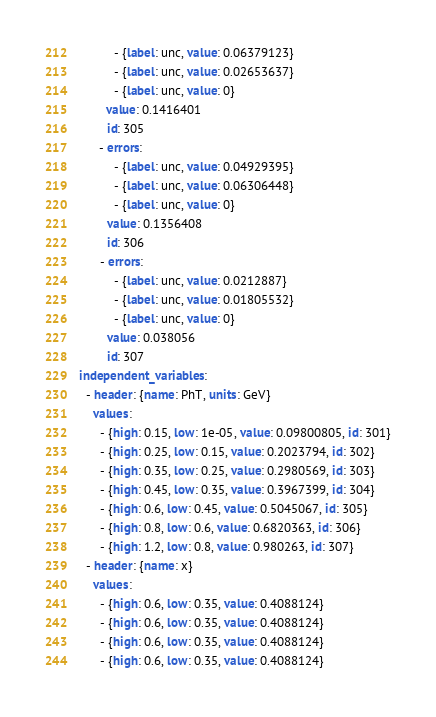Convert code to text. <code><loc_0><loc_0><loc_500><loc_500><_YAML_>          - {label: unc, value: 0.06379123}
          - {label: unc, value: 0.02653637}
          - {label: unc, value: 0}
        value: 0.1416401
        id: 305
      - errors:
          - {label: unc, value: 0.04929395}
          - {label: unc, value: 0.06306448}
          - {label: unc, value: 0}
        value: 0.1356408
        id: 306
      - errors:
          - {label: unc, value: 0.0212887}
          - {label: unc, value: 0.01805532}
          - {label: unc, value: 0}
        value: 0.038056
        id: 307
independent_variables:
  - header: {name: PhT, units: GeV}
    values:
      - {high: 0.15, low: 1e-05, value: 0.09800805, id: 301}
      - {high: 0.25, low: 0.15, value: 0.2023794, id: 302}
      - {high: 0.35, low: 0.25, value: 0.2980569, id: 303}
      - {high: 0.45, low: 0.35, value: 0.3967399, id: 304}
      - {high: 0.6, low: 0.45, value: 0.5045067, id: 305}
      - {high: 0.8, low: 0.6, value: 0.6820363, id: 306}
      - {high: 1.2, low: 0.8, value: 0.980263, id: 307}
  - header: {name: x}
    values:
      - {high: 0.6, low: 0.35, value: 0.4088124}
      - {high: 0.6, low: 0.35, value: 0.4088124}
      - {high: 0.6, low: 0.35, value: 0.4088124}
      - {high: 0.6, low: 0.35, value: 0.4088124}</code> 